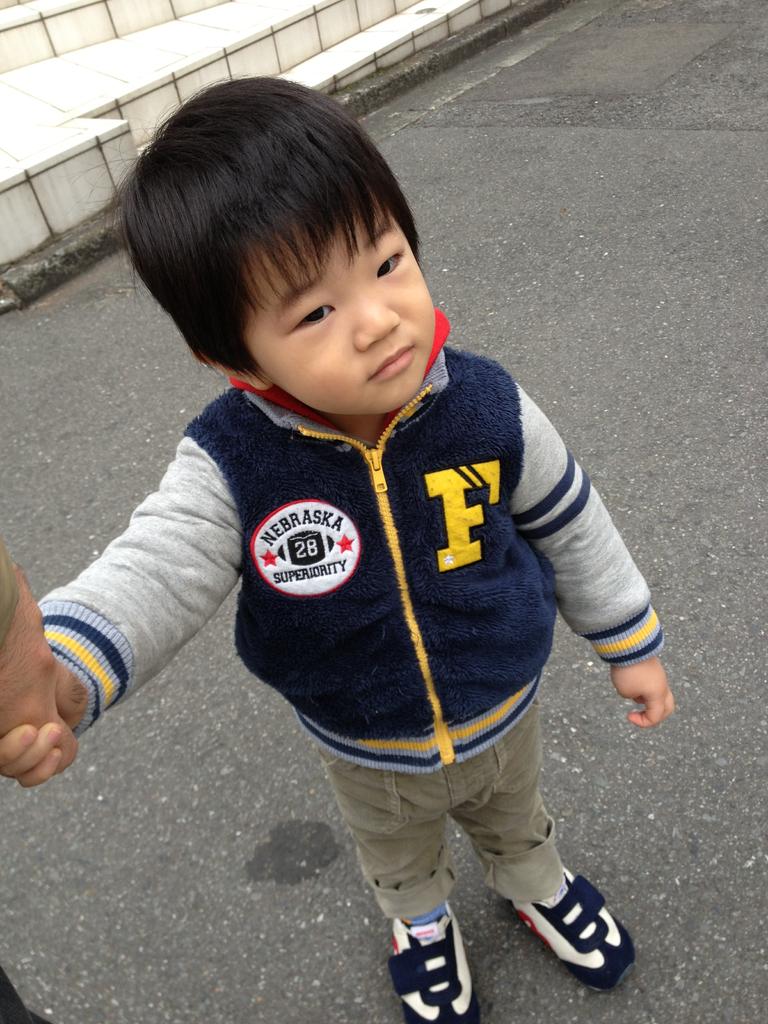What letter is on the little boy's jacket?
Your response must be concise. F. What word is written at the top of the circle on the left?
Provide a short and direct response. Nebraska. 